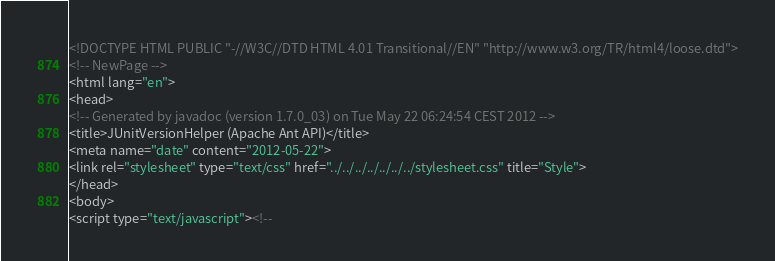<code> <loc_0><loc_0><loc_500><loc_500><_HTML_><!DOCTYPE HTML PUBLIC "-//W3C//DTD HTML 4.01 Transitional//EN" "http://www.w3.org/TR/html4/loose.dtd">
<!-- NewPage -->
<html lang="en">
<head>
<!-- Generated by javadoc (version 1.7.0_03) on Tue May 22 06:24:54 CEST 2012 -->
<title>JUnitVersionHelper (Apache Ant API)</title>
<meta name="date" content="2012-05-22">
<link rel="stylesheet" type="text/css" href="../../../../../../../stylesheet.css" title="Style">
</head>
<body>
<script type="text/javascript"><!--</code> 